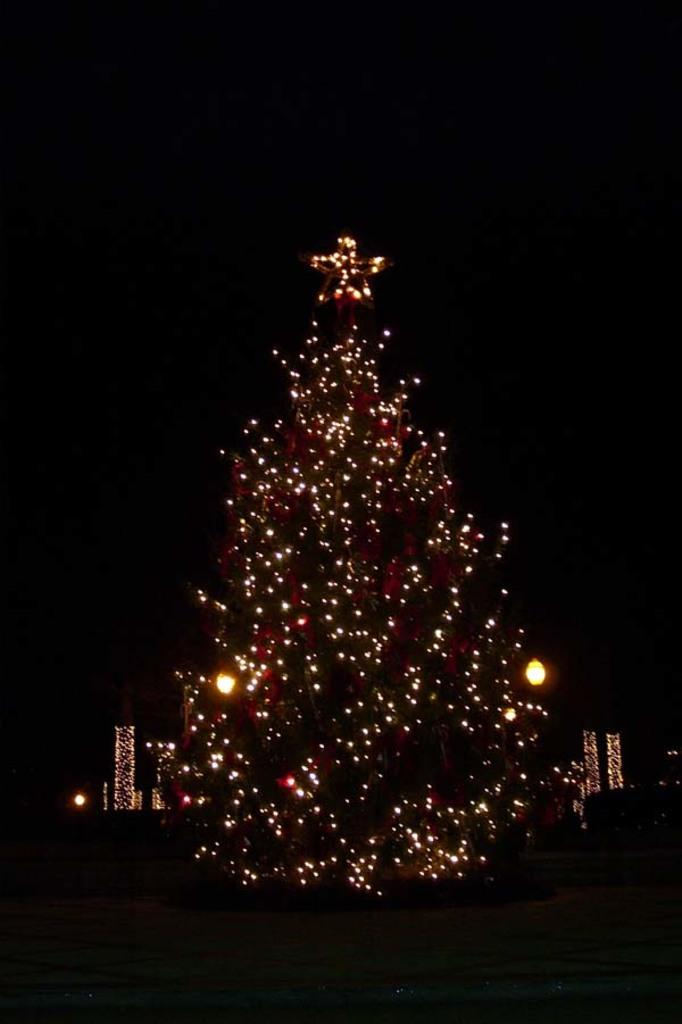What can be seen in the image that emits light? There are lights visible in the image. What type of zinc is present in the image? There is no zinc present in the image. What amusement can be seen in the image? The image does not depict any amusement; it only shows lights. 